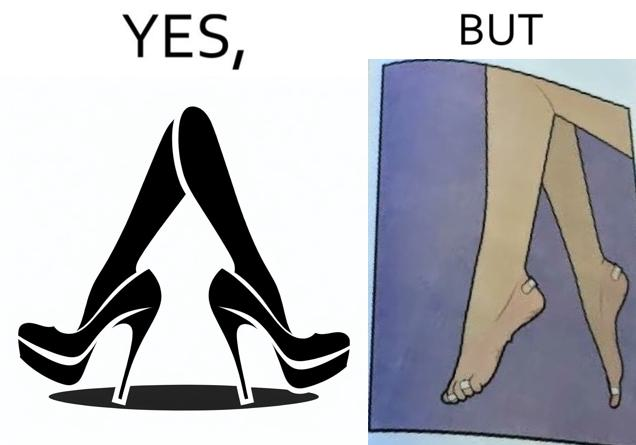Why is this image considered satirical? The images are funny since they show how the prettiest footwears like high heels, end up causing a lot of physical discomfort to the user, all in the name fashion 